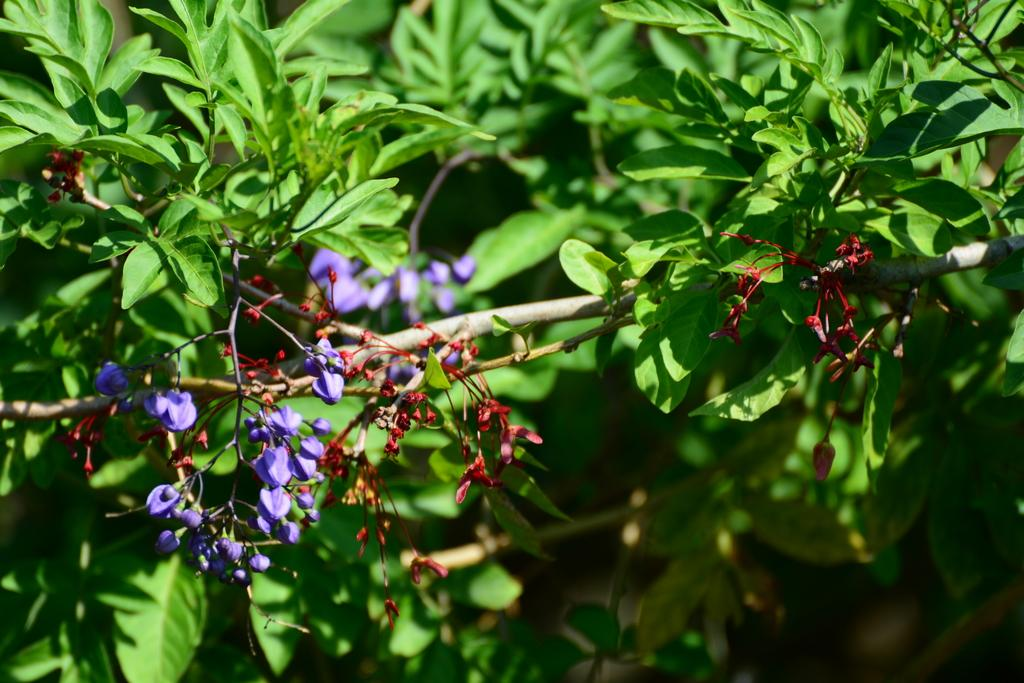What type of living organisms can be seen in the image? Plants and flowers are visible in the image. What colors are the flowers in the image? The flowers in the image are in red and violet colors. What type of haircut is the flower receiving in the image? There is no haircut present in the image, as flowers do not have hair. 